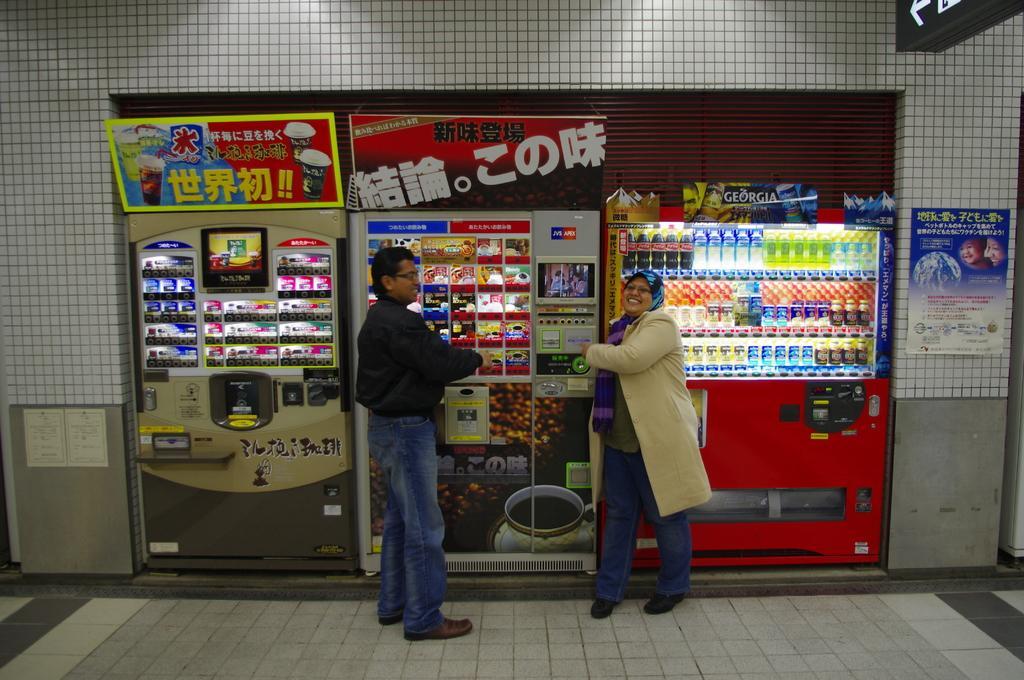How would you summarize this image in a sentence or two? In the image we can see a man and a woman. They are wearing clothes, shoes and spectacles. These are the food items, this is a machine, floor and a poster. 